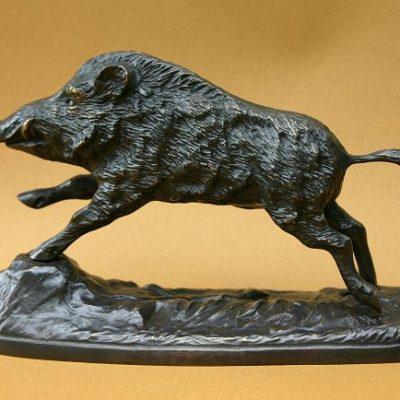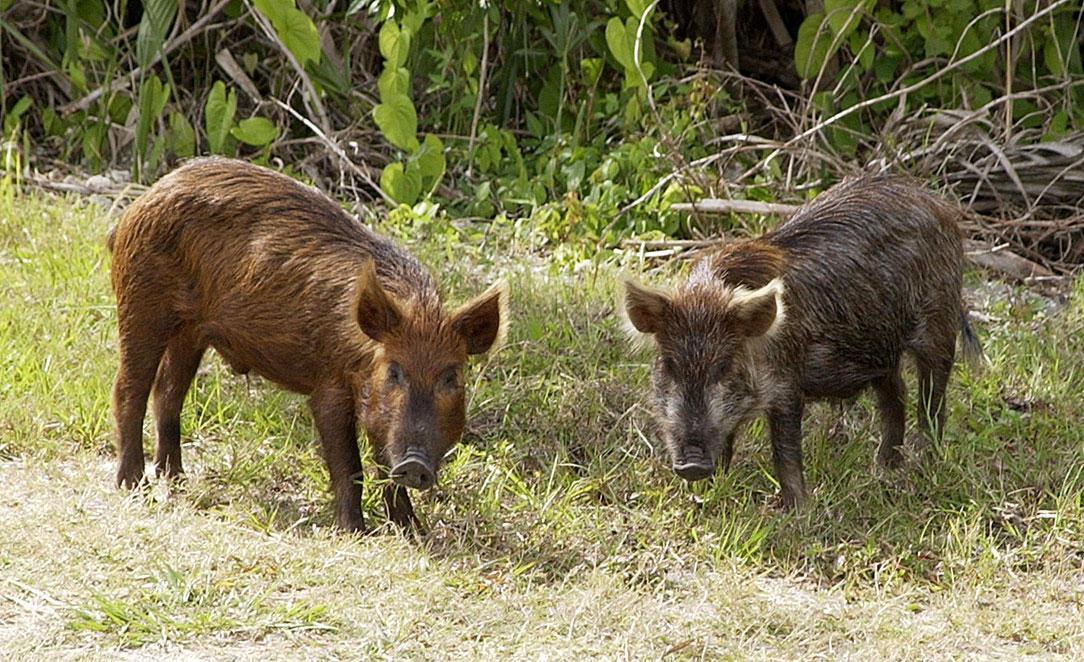The first image is the image on the left, the second image is the image on the right. Analyze the images presented: Is the assertion "One image shows an actual wild pig bounding across the ground in profile, and each image includes an animal figure in a motion pose." valid? Answer yes or no. No. The first image is the image on the left, the second image is the image on the right. For the images shown, is this caption "At least one wild boar is running toward the right, and another wild boar is running toward the left." true? Answer yes or no. No. 